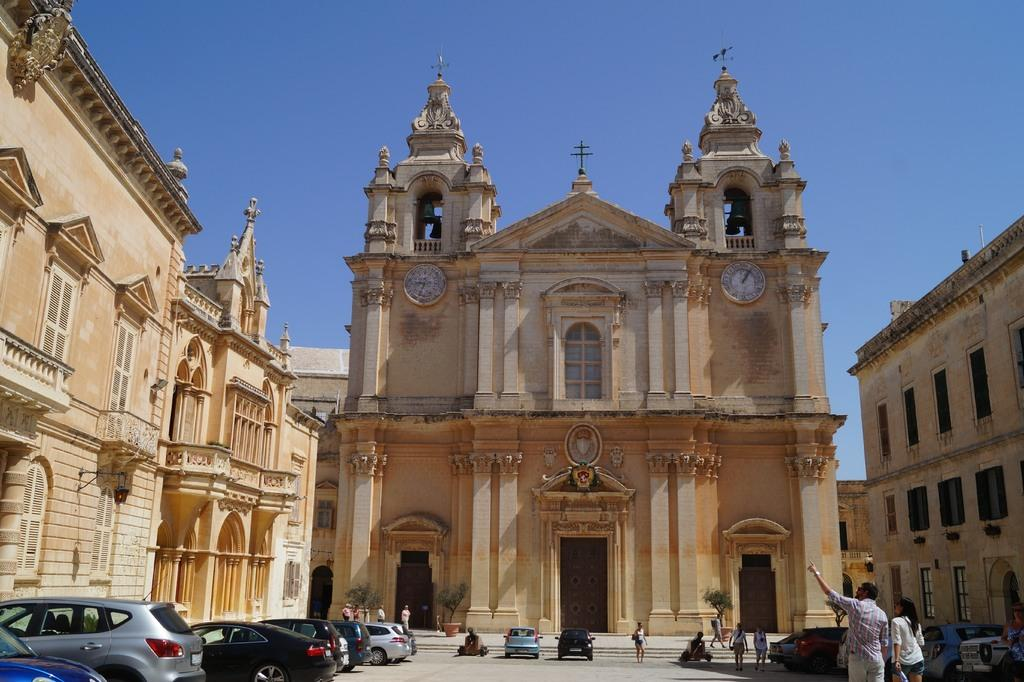Who or what is present in the image? There are people in the image. What else can be seen in the image besides people? There are vehicles and buildings in the image. Are there any time-related objects in the image? Yes, there are clocks on the wall in the image. What can be seen in the background of the image? The sky is visible in the background of the image. What flavor of shoes can be seen on the people in the image? There are no shoes mentioned in the image, and therefore no flavor can be associated with them. 